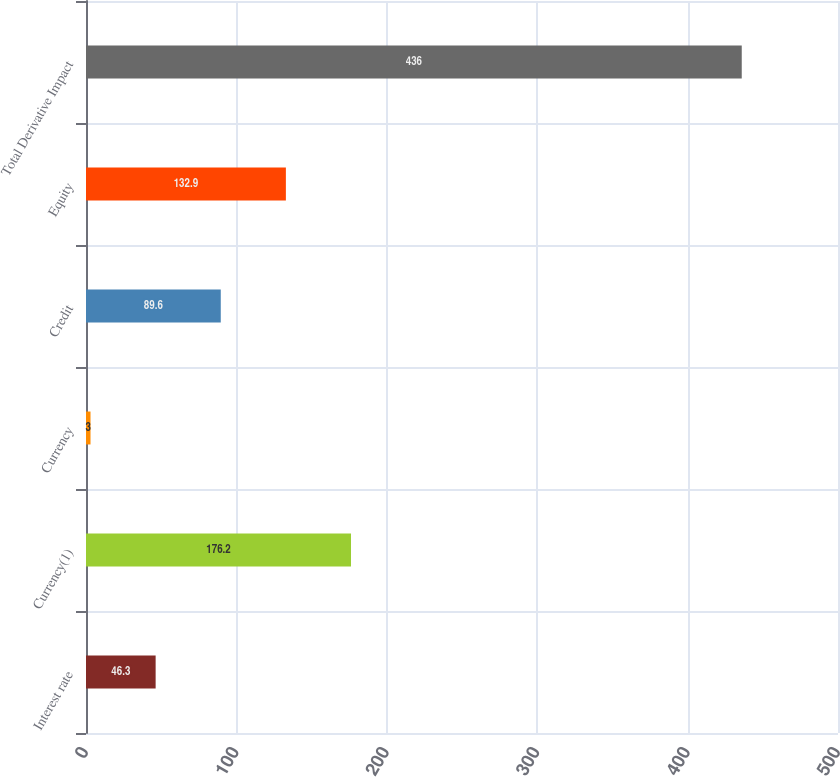Convert chart. <chart><loc_0><loc_0><loc_500><loc_500><bar_chart><fcel>Interest rate<fcel>Currency(1)<fcel>Currency<fcel>Credit<fcel>Equity<fcel>Total Derivative Impact<nl><fcel>46.3<fcel>176.2<fcel>3<fcel>89.6<fcel>132.9<fcel>436<nl></chart> 